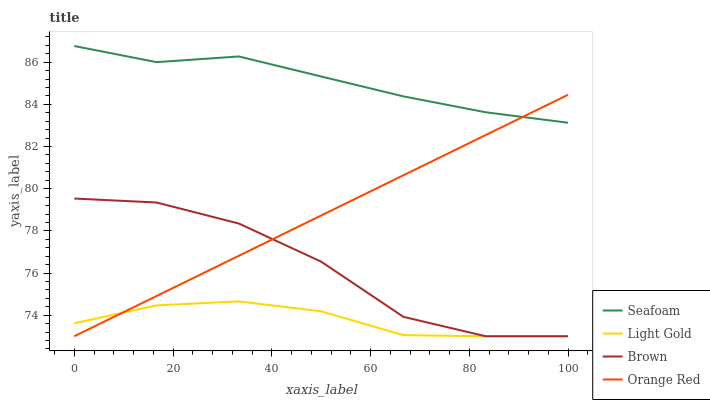Does Seafoam have the minimum area under the curve?
Answer yes or no. No. Does Light Gold have the maximum area under the curve?
Answer yes or no. No. Is Light Gold the smoothest?
Answer yes or no. No. Is Light Gold the roughest?
Answer yes or no. No. Does Seafoam have the lowest value?
Answer yes or no. No. Does Light Gold have the highest value?
Answer yes or no. No. Is Light Gold less than Seafoam?
Answer yes or no. Yes. Is Seafoam greater than Brown?
Answer yes or no. Yes. Does Light Gold intersect Seafoam?
Answer yes or no. No. 